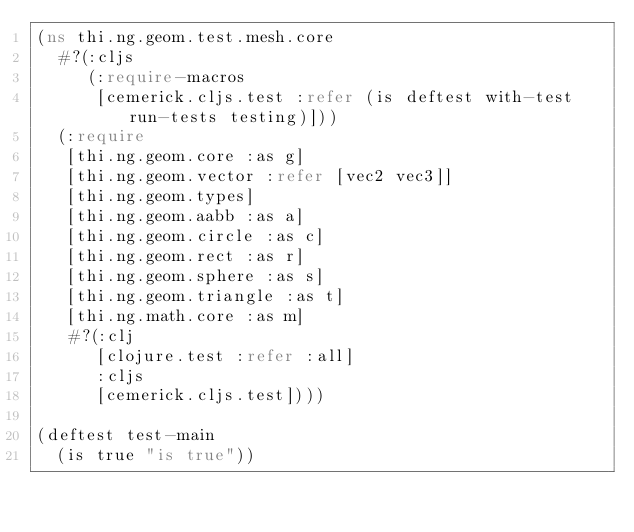Convert code to text. <code><loc_0><loc_0><loc_500><loc_500><_Clojure_>(ns thi.ng.geom.test.mesh.core
  #?(:cljs
     (:require-macros
      [cemerick.cljs.test :refer (is deftest with-test run-tests testing)]))
  (:require
   [thi.ng.geom.core :as g]
   [thi.ng.geom.vector :refer [vec2 vec3]]
   [thi.ng.geom.types]
   [thi.ng.geom.aabb :as a]
   [thi.ng.geom.circle :as c]
   [thi.ng.geom.rect :as r]
   [thi.ng.geom.sphere :as s]
   [thi.ng.geom.triangle :as t]
   [thi.ng.math.core :as m]
   #?(:clj
      [clojure.test :refer :all]
      :cljs
      [cemerick.cljs.test])))

(deftest test-main
  (is true "is true"))
</code> 